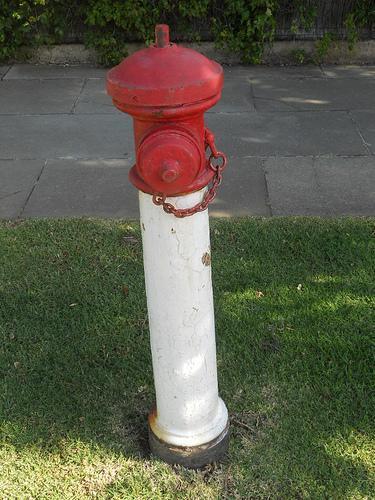How many fire hydrant are there?
Give a very brief answer. 1. 